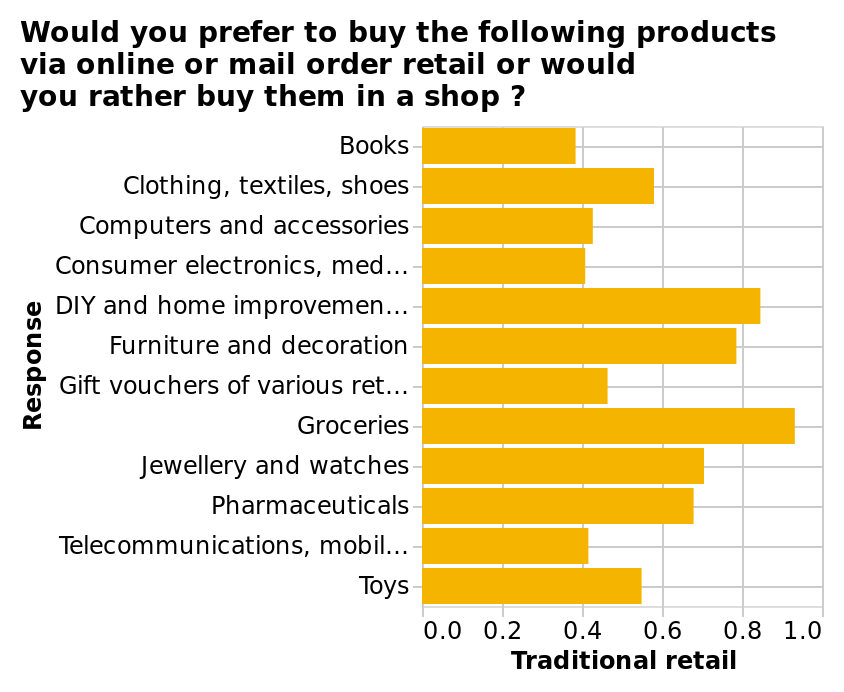<image>
How are the responses of the survey represented in the bar plot?  The responses of the survey are represented by the height of the bars on the y-axis. 